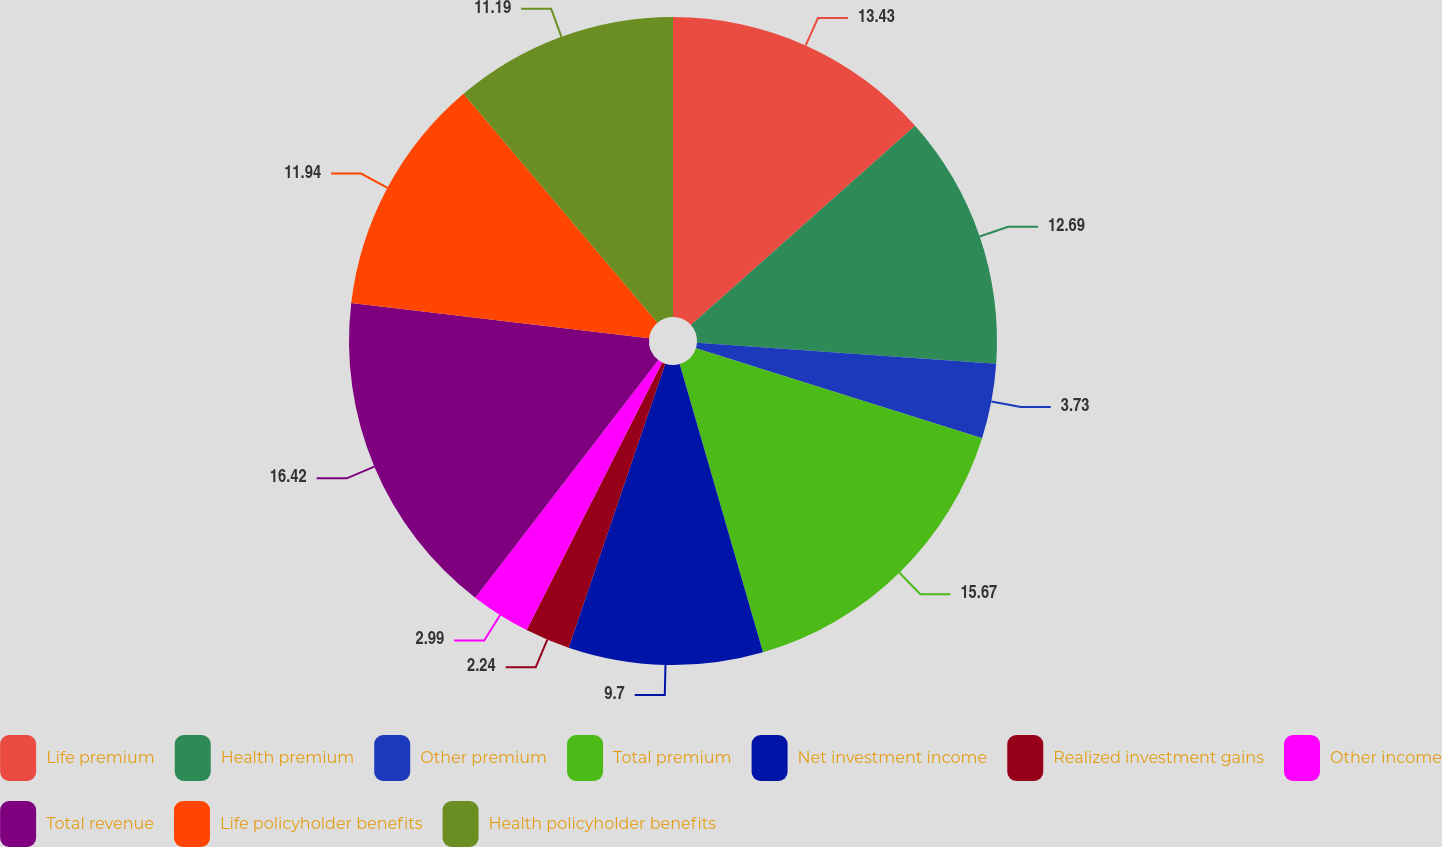Convert chart to OTSL. <chart><loc_0><loc_0><loc_500><loc_500><pie_chart><fcel>Life premium<fcel>Health premium<fcel>Other premium<fcel>Total premium<fcel>Net investment income<fcel>Realized investment gains<fcel>Other income<fcel>Total revenue<fcel>Life policyholder benefits<fcel>Health policyholder benefits<nl><fcel>13.43%<fcel>12.69%<fcel>3.73%<fcel>15.67%<fcel>9.7%<fcel>2.24%<fcel>2.99%<fcel>16.42%<fcel>11.94%<fcel>11.19%<nl></chart> 